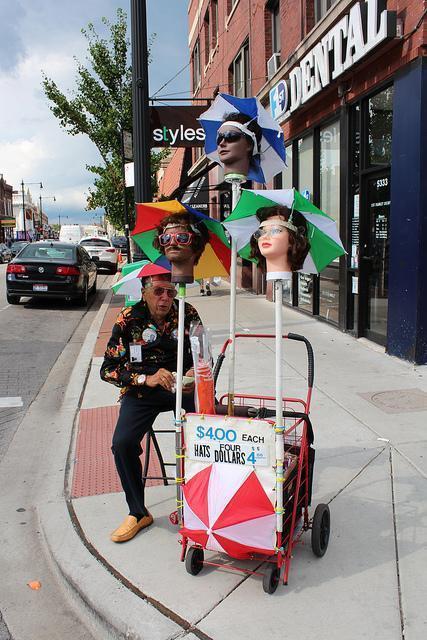How many umbrellas are there?
Give a very brief answer. 4. 